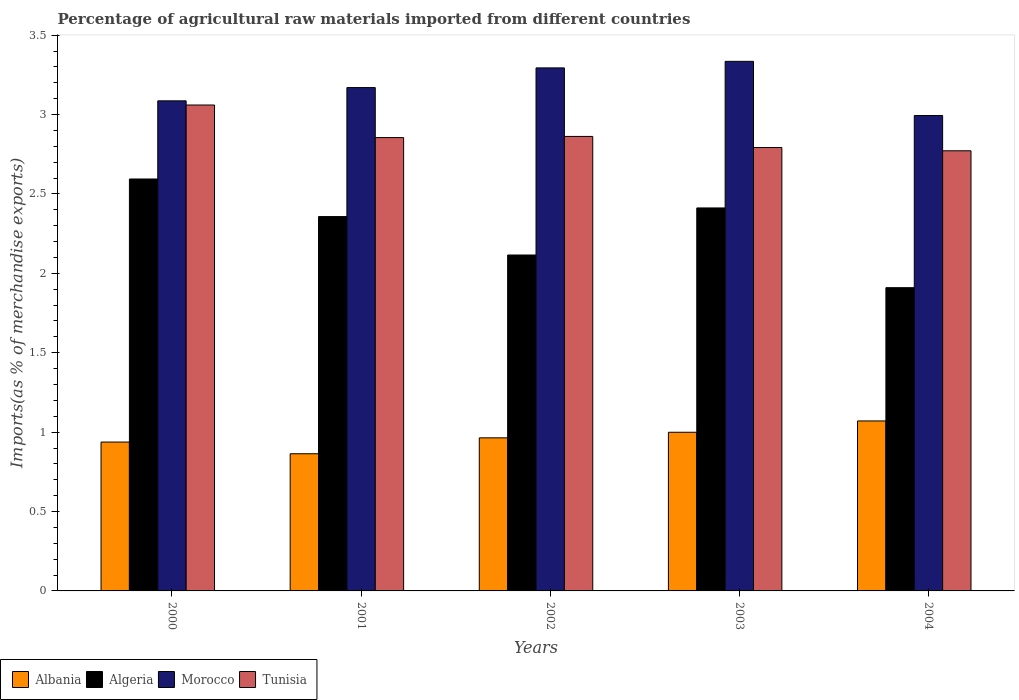How many groups of bars are there?
Provide a short and direct response. 5. In how many cases, is the number of bars for a given year not equal to the number of legend labels?
Give a very brief answer. 0. What is the percentage of imports to different countries in Tunisia in 2003?
Give a very brief answer. 2.79. Across all years, what is the maximum percentage of imports to different countries in Albania?
Provide a succinct answer. 1.07. Across all years, what is the minimum percentage of imports to different countries in Morocco?
Provide a short and direct response. 2.99. In which year was the percentage of imports to different countries in Tunisia minimum?
Ensure brevity in your answer.  2004. What is the total percentage of imports to different countries in Tunisia in the graph?
Keep it short and to the point. 14.34. What is the difference between the percentage of imports to different countries in Albania in 2002 and that in 2003?
Your response must be concise. -0.04. What is the difference between the percentage of imports to different countries in Tunisia in 2000 and the percentage of imports to different countries in Albania in 2001?
Your answer should be very brief. 2.2. What is the average percentage of imports to different countries in Algeria per year?
Provide a succinct answer. 2.28. In the year 2001, what is the difference between the percentage of imports to different countries in Tunisia and percentage of imports to different countries in Albania?
Your response must be concise. 1.99. What is the ratio of the percentage of imports to different countries in Albania in 2002 to that in 2004?
Offer a very short reply. 0.9. Is the percentage of imports to different countries in Algeria in 2003 less than that in 2004?
Offer a very short reply. No. Is the difference between the percentage of imports to different countries in Tunisia in 2001 and 2004 greater than the difference between the percentage of imports to different countries in Albania in 2001 and 2004?
Your answer should be very brief. Yes. What is the difference between the highest and the second highest percentage of imports to different countries in Albania?
Your answer should be compact. 0.07. What is the difference between the highest and the lowest percentage of imports to different countries in Algeria?
Provide a short and direct response. 0.68. Is the sum of the percentage of imports to different countries in Tunisia in 2002 and 2004 greater than the maximum percentage of imports to different countries in Albania across all years?
Your response must be concise. Yes. Is it the case that in every year, the sum of the percentage of imports to different countries in Tunisia and percentage of imports to different countries in Morocco is greater than the sum of percentage of imports to different countries in Albania and percentage of imports to different countries in Algeria?
Give a very brief answer. Yes. What does the 3rd bar from the left in 2004 represents?
Offer a very short reply. Morocco. What does the 2nd bar from the right in 2003 represents?
Your response must be concise. Morocco. How many bars are there?
Your answer should be very brief. 20. Are all the bars in the graph horizontal?
Offer a very short reply. No. How many years are there in the graph?
Give a very brief answer. 5. Are the values on the major ticks of Y-axis written in scientific E-notation?
Make the answer very short. No. Does the graph contain any zero values?
Provide a short and direct response. No. How many legend labels are there?
Provide a short and direct response. 4. How are the legend labels stacked?
Ensure brevity in your answer.  Horizontal. What is the title of the graph?
Provide a succinct answer. Percentage of agricultural raw materials imported from different countries. What is the label or title of the Y-axis?
Ensure brevity in your answer.  Imports(as % of merchandise exports). What is the Imports(as % of merchandise exports) of Albania in 2000?
Ensure brevity in your answer.  0.94. What is the Imports(as % of merchandise exports) in Algeria in 2000?
Ensure brevity in your answer.  2.59. What is the Imports(as % of merchandise exports) in Morocco in 2000?
Keep it short and to the point. 3.09. What is the Imports(as % of merchandise exports) in Tunisia in 2000?
Offer a very short reply. 3.06. What is the Imports(as % of merchandise exports) in Albania in 2001?
Give a very brief answer. 0.86. What is the Imports(as % of merchandise exports) in Algeria in 2001?
Offer a terse response. 2.36. What is the Imports(as % of merchandise exports) of Morocco in 2001?
Your answer should be compact. 3.17. What is the Imports(as % of merchandise exports) of Tunisia in 2001?
Offer a very short reply. 2.85. What is the Imports(as % of merchandise exports) in Albania in 2002?
Provide a succinct answer. 0.96. What is the Imports(as % of merchandise exports) in Algeria in 2002?
Provide a succinct answer. 2.12. What is the Imports(as % of merchandise exports) of Morocco in 2002?
Ensure brevity in your answer.  3.29. What is the Imports(as % of merchandise exports) in Tunisia in 2002?
Provide a succinct answer. 2.86. What is the Imports(as % of merchandise exports) in Albania in 2003?
Ensure brevity in your answer.  1. What is the Imports(as % of merchandise exports) in Algeria in 2003?
Your answer should be compact. 2.41. What is the Imports(as % of merchandise exports) of Morocco in 2003?
Give a very brief answer. 3.34. What is the Imports(as % of merchandise exports) of Tunisia in 2003?
Make the answer very short. 2.79. What is the Imports(as % of merchandise exports) in Albania in 2004?
Keep it short and to the point. 1.07. What is the Imports(as % of merchandise exports) of Algeria in 2004?
Give a very brief answer. 1.91. What is the Imports(as % of merchandise exports) of Morocco in 2004?
Keep it short and to the point. 2.99. What is the Imports(as % of merchandise exports) of Tunisia in 2004?
Provide a succinct answer. 2.77. Across all years, what is the maximum Imports(as % of merchandise exports) of Albania?
Your answer should be very brief. 1.07. Across all years, what is the maximum Imports(as % of merchandise exports) of Algeria?
Give a very brief answer. 2.59. Across all years, what is the maximum Imports(as % of merchandise exports) of Morocco?
Your response must be concise. 3.34. Across all years, what is the maximum Imports(as % of merchandise exports) in Tunisia?
Your answer should be compact. 3.06. Across all years, what is the minimum Imports(as % of merchandise exports) of Albania?
Offer a very short reply. 0.86. Across all years, what is the minimum Imports(as % of merchandise exports) in Algeria?
Offer a terse response. 1.91. Across all years, what is the minimum Imports(as % of merchandise exports) in Morocco?
Ensure brevity in your answer.  2.99. Across all years, what is the minimum Imports(as % of merchandise exports) of Tunisia?
Make the answer very short. 2.77. What is the total Imports(as % of merchandise exports) of Albania in the graph?
Give a very brief answer. 4.84. What is the total Imports(as % of merchandise exports) in Algeria in the graph?
Make the answer very short. 11.39. What is the total Imports(as % of merchandise exports) in Morocco in the graph?
Ensure brevity in your answer.  15.88. What is the total Imports(as % of merchandise exports) in Tunisia in the graph?
Provide a short and direct response. 14.34. What is the difference between the Imports(as % of merchandise exports) in Albania in 2000 and that in 2001?
Provide a succinct answer. 0.07. What is the difference between the Imports(as % of merchandise exports) of Algeria in 2000 and that in 2001?
Your response must be concise. 0.24. What is the difference between the Imports(as % of merchandise exports) of Morocco in 2000 and that in 2001?
Provide a short and direct response. -0.08. What is the difference between the Imports(as % of merchandise exports) in Tunisia in 2000 and that in 2001?
Provide a short and direct response. 0.21. What is the difference between the Imports(as % of merchandise exports) in Albania in 2000 and that in 2002?
Keep it short and to the point. -0.03. What is the difference between the Imports(as % of merchandise exports) in Algeria in 2000 and that in 2002?
Ensure brevity in your answer.  0.48. What is the difference between the Imports(as % of merchandise exports) in Morocco in 2000 and that in 2002?
Your answer should be compact. -0.21. What is the difference between the Imports(as % of merchandise exports) of Tunisia in 2000 and that in 2002?
Provide a succinct answer. 0.2. What is the difference between the Imports(as % of merchandise exports) of Albania in 2000 and that in 2003?
Ensure brevity in your answer.  -0.06. What is the difference between the Imports(as % of merchandise exports) of Algeria in 2000 and that in 2003?
Give a very brief answer. 0.18. What is the difference between the Imports(as % of merchandise exports) of Morocco in 2000 and that in 2003?
Provide a short and direct response. -0.25. What is the difference between the Imports(as % of merchandise exports) of Tunisia in 2000 and that in 2003?
Provide a succinct answer. 0.27. What is the difference between the Imports(as % of merchandise exports) in Albania in 2000 and that in 2004?
Provide a succinct answer. -0.13. What is the difference between the Imports(as % of merchandise exports) of Algeria in 2000 and that in 2004?
Offer a terse response. 0.68. What is the difference between the Imports(as % of merchandise exports) in Morocco in 2000 and that in 2004?
Your answer should be very brief. 0.09. What is the difference between the Imports(as % of merchandise exports) in Tunisia in 2000 and that in 2004?
Your answer should be very brief. 0.29. What is the difference between the Imports(as % of merchandise exports) of Albania in 2001 and that in 2002?
Your answer should be compact. -0.1. What is the difference between the Imports(as % of merchandise exports) in Algeria in 2001 and that in 2002?
Provide a short and direct response. 0.24. What is the difference between the Imports(as % of merchandise exports) in Morocco in 2001 and that in 2002?
Provide a succinct answer. -0.12. What is the difference between the Imports(as % of merchandise exports) in Tunisia in 2001 and that in 2002?
Provide a short and direct response. -0.01. What is the difference between the Imports(as % of merchandise exports) of Albania in 2001 and that in 2003?
Give a very brief answer. -0.14. What is the difference between the Imports(as % of merchandise exports) in Algeria in 2001 and that in 2003?
Your answer should be very brief. -0.05. What is the difference between the Imports(as % of merchandise exports) of Morocco in 2001 and that in 2003?
Provide a succinct answer. -0.17. What is the difference between the Imports(as % of merchandise exports) of Tunisia in 2001 and that in 2003?
Offer a terse response. 0.06. What is the difference between the Imports(as % of merchandise exports) of Albania in 2001 and that in 2004?
Offer a very short reply. -0.21. What is the difference between the Imports(as % of merchandise exports) in Algeria in 2001 and that in 2004?
Offer a very short reply. 0.45. What is the difference between the Imports(as % of merchandise exports) in Morocco in 2001 and that in 2004?
Make the answer very short. 0.18. What is the difference between the Imports(as % of merchandise exports) of Tunisia in 2001 and that in 2004?
Provide a succinct answer. 0.08. What is the difference between the Imports(as % of merchandise exports) in Albania in 2002 and that in 2003?
Offer a terse response. -0.04. What is the difference between the Imports(as % of merchandise exports) of Algeria in 2002 and that in 2003?
Offer a terse response. -0.3. What is the difference between the Imports(as % of merchandise exports) in Morocco in 2002 and that in 2003?
Ensure brevity in your answer.  -0.04. What is the difference between the Imports(as % of merchandise exports) of Tunisia in 2002 and that in 2003?
Your answer should be compact. 0.07. What is the difference between the Imports(as % of merchandise exports) of Albania in 2002 and that in 2004?
Keep it short and to the point. -0.11. What is the difference between the Imports(as % of merchandise exports) of Algeria in 2002 and that in 2004?
Your response must be concise. 0.21. What is the difference between the Imports(as % of merchandise exports) of Morocco in 2002 and that in 2004?
Provide a succinct answer. 0.3. What is the difference between the Imports(as % of merchandise exports) in Tunisia in 2002 and that in 2004?
Ensure brevity in your answer.  0.09. What is the difference between the Imports(as % of merchandise exports) in Albania in 2003 and that in 2004?
Keep it short and to the point. -0.07. What is the difference between the Imports(as % of merchandise exports) of Algeria in 2003 and that in 2004?
Your answer should be very brief. 0.5. What is the difference between the Imports(as % of merchandise exports) in Morocco in 2003 and that in 2004?
Make the answer very short. 0.34. What is the difference between the Imports(as % of merchandise exports) in Tunisia in 2003 and that in 2004?
Keep it short and to the point. 0.02. What is the difference between the Imports(as % of merchandise exports) of Albania in 2000 and the Imports(as % of merchandise exports) of Algeria in 2001?
Ensure brevity in your answer.  -1.42. What is the difference between the Imports(as % of merchandise exports) in Albania in 2000 and the Imports(as % of merchandise exports) in Morocco in 2001?
Offer a terse response. -2.23. What is the difference between the Imports(as % of merchandise exports) in Albania in 2000 and the Imports(as % of merchandise exports) in Tunisia in 2001?
Provide a succinct answer. -1.92. What is the difference between the Imports(as % of merchandise exports) in Algeria in 2000 and the Imports(as % of merchandise exports) in Morocco in 2001?
Ensure brevity in your answer.  -0.58. What is the difference between the Imports(as % of merchandise exports) in Algeria in 2000 and the Imports(as % of merchandise exports) in Tunisia in 2001?
Keep it short and to the point. -0.26. What is the difference between the Imports(as % of merchandise exports) of Morocco in 2000 and the Imports(as % of merchandise exports) of Tunisia in 2001?
Provide a succinct answer. 0.23. What is the difference between the Imports(as % of merchandise exports) in Albania in 2000 and the Imports(as % of merchandise exports) in Algeria in 2002?
Offer a very short reply. -1.18. What is the difference between the Imports(as % of merchandise exports) of Albania in 2000 and the Imports(as % of merchandise exports) of Morocco in 2002?
Your response must be concise. -2.36. What is the difference between the Imports(as % of merchandise exports) in Albania in 2000 and the Imports(as % of merchandise exports) in Tunisia in 2002?
Your answer should be compact. -1.92. What is the difference between the Imports(as % of merchandise exports) of Algeria in 2000 and the Imports(as % of merchandise exports) of Morocco in 2002?
Make the answer very short. -0.7. What is the difference between the Imports(as % of merchandise exports) of Algeria in 2000 and the Imports(as % of merchandise exports) of Tunisia in 2002?
Offer a terse response. -0.27. What is the difference between the Imports(as % of merchandise exports) of Morocco in 2000 and the Imports(as % of merchandise exports) of Tunisia in 2002?
Your response must be concise. 0.22. What is the difference between the Imports(as % of merchandise exports) of Albania in 2000 and the Imports(as % of merchandise exports) of Algeria in 2003?
Provide a short and direct response. -1.47. What is the difference between the Imports(as % of merchandise exports) of Albania in 2000 and the Imports(as % of merchandise exports) of Morocco in 2003?
Keep it short and to the point. -2.4. What is the difference between the Imports(as % of merchandise exports) of Albania in 2000 and the Imports(as % of merchandise exports) of Tunisia in 2003?
Ensure brevity in your answer.  -1.85. What is the difference between the Imports(as % of merchandise exports) of Algeria in 2000 and the Imports(as % of merchandise exports) of Morocco in 2003?
Keep it short and to the point. -0.74. What is the difference between the Imports(as % of merchandise exports) of Algeria in 2000 and the Imports(as % of merchandise exports) of Tunisia in 2003?
Provide a succinct answer. -0.2. What is the difference between the Imports(as % of merchandise exports) of Morocco in 2000 and the Imports(as % of merchandise exports) of Tunisia in 2003?
Your answer should be compact. 0.29. What is the difference between the Imports(as % of merchandise exports) in Albania in 2000 and the Imports(as % of merchandise exports) in Algeria in 2004?
Give a very brief answer. -0.97. What is the difference between the Imports(as % of merchandise exports) in Albania in 2000 and the Imports(as % of merchandise exports) in Morocco in 2004?
Provide a short and direct response. -2.06. What is the difference between the Imports(as % of merchandise exports) of Albania in 2000 and the Imports(as % of merchandise exports) of Tunisia in 2004?
Your answer should be very brief. -1.83. What is the difference between the Imports(as % of merchandise exports) of Algeria in 2000 and the Imports(as % of merchandise exports) of Morocco in 2004?
Keep it short and to the point. -0.4. What is the difference between the Imports(as % of merchandise exports) in Algeria in 2000 and the Imports(as % of merchandise exports) in Tunisia in 2004?
Give a very brief answer. -0.18. What is the difference between the Imports(as % of merchandise exports) of Morocco in 2000 and the Imports(as % of merchandise exports) of Tunisia in 2004?
Ensure brevity in your answer.  0.31. What is the difference between the Imports(as % of merchandise exports) of Albania in 2001 and the Imports(as % of merchandise exports) of Algeria in 2002?
Your answer should be very brief. -1.25. What is the difference between the Imports(as % of merchandise exports) in Albania in 2001 and the Imports(as % of merchandise exports) in Morocco in 2002?
Provide a succinct answer. -2.43. What is the difference between the Imports(as % of merchandise exports) of Albania in 2001 and the Imports(as % of merchandise exports) of Tunisia in 2002?
Your response must be concise. -2. What is the difference between the Imports(as % of merchandise exports) in Algeria in 2001 and the Imports(as % of merchandise exports) in Morocco in 2002?
Your answer should be very brief. -0.94. What is the difference between the Imports(as % of merchandise exports) of Algeria in 2001 and the Imports(as % of merchandise exports) of Tunisia in 2002?
Ensure brevity in your answer.  -0.5. What is the difference between the Imports(as % of merchandise exports) of Morocco in 2001 and the Imports(as % of merchandise exports) of Tunisia in 2002?
Make the answer very short. 0.31. What is the difference between the Imports(as % of merchandise exports) of Albania in 2001 and the Imports(as % of merchandise exports) of Algeria in 2003?
Keep it short and to the point. -1.55. What is the difference between the Imports(as % of merchandise exports) of Albania in 2001 and the Imports(as % of merchandise exports) of Morocco in 2003?
Your response must be concise. -2.47. What is the difference between the Imports(as % of merchandise exports) in Albania in 2001 and the Imports(as % of merchandise exports) in Tunisia in 2003?
Provide a succinct answer. -1.93. What is the difference between the Imports(as % of merchandise exports) in Algeria in 2001 and the Imports(as % of merchandise exports) in Morocco in 2003?
Provide a succinct answer. -0.98. What is the difference between the Imports(as % of merchandise exports) in Algeria in 2001 and the Imports(as % of merchandise exports) in Tunisia in 2003?
Give a very brief answer. -0.43. What is the difference between the Imports(as % of merchandise exports) of Morocco in 2001 and the Imports(as % of merchandise exports) of Tunisia in 2003?
Provide a short and direct response. 0.38. What is the difference between the Imports(as % of merchandise exports) of Albania in 2001 and the Imports(as % of merchandise exports) of Algeria in 2004?
Your answer should be compact. -1.05. What is the difference between the Imports(as % of merchandise exports) in Albania in 2001 and the Imports(as % of merchandise exports) in Morocco in 2004?
Your response must be concise. -2.13. What is the difference between the Imports(as % of merchandise exports) in Albania in 2001 and the Imports(as % of merchandise exports) in Tunisia in 2004?
Provide a short and direct response. -1.91. What is the difference between the Imports(as % of merchandise exports) in Algeria in 2001 and the Imports(as % of merchandise exports) in Morocco in 2004?
Ensure brevity in your answer.  -0.64. What is the difference between the Imports(as % of merchandise exports) in Algeria in 2001 and the Imports(as % of merchandise exports) in Tunisia in 2004?
Provide a succinct answer. -0.41. What is the difference between the Imports(as % of merchandise exports) in Morocco in 2001 and the Imports(as % of merchandise exports) in Tunisia in 2004?
Ensure brevity in your answer.  0.4. What is the difference between the Imports(as % of merchandise exports) in Albania in 2002 and the Imports(as % of merchandise exports) in Algeria in 2003?
Keep it short and to the point. -1.45. What is the difference between the Imports(as % of merchandise exports) in Albania in 2002 and the Imports(as % of merchandise exports) in Morocco in 2003?
Provide a short and direct response. -2.37. What is the difference between the Imports(as % of merchandise exports) in Albania in 2002 and the Imports(as % of merchandise exports) in Tunisia in 2003?
Offer a terse response. -1.83. What is the difference between the Imports(as % of merchandise exports) in Algeria in 2002 and the Imports(as % of merchandise exports) in Morocco in 2003?
Your response must be concise. -1.22. What is the difference between the Imports(as % of merchandise exports) of Algeria in 2002 and the Imports(as % of merchandise exports) of Tunisia in 2003?
Offer a terse response. -0.68. What is the difference between the Imports(as % of merchandise exports) in Morocco in 2002 and the Imports(as % of merchandise exports) in Tunisia in 2003?
Offer a very short reply. 0.5. What is the difference between the Imports(as % of merchandise exports) in Albania in 2002 and the Imports(as % of merchandise exports) in Algeria in 2004?
Make the answer very short. -0.95. What is the difference between the Imports(as % of merchandise exports) in Albania in 2002 and the Imports(as % of merchandise exports) in Morocco in 2004?
Make the answer very short. -2.03. What is the difference between the Imports(as % of merchandise exports) of Albania in 2002 and the Imports(as % of merchandise exports) of Tunisia in 2004?
Your response must be concise. -1.81. What is the difference between the Imports(as % of merchandise exports) in Algeria in 2002 and the Imports(as % of merchandise exports) in Morocco in 2004?
Give a very brief answer. -0.88. What is the difference between the Imports(as % of merchandise exports) in Algeria in 2002 and the Imports(as % of merchandise exports) in Tunisia in 2004?
Offer a very short reply. -0.66. What is the difference between the Imports(as % of merchandise exports) of Morocco in 2002 and the Imports(as % of merchandise exports) of Tunisia in 2004?
Offer a very short reply. 0.52. What is the difference between the Imports(as % of merchandise exports) in Albania in 2003 and the Imports(as % of merchandise exports) in Algeria in 2004?
Ensure brevity in your answer.  -0.91. What is the difference between the Imports(as % of merchandise exports) in Albania in 2003 and the Imports(as % of merchandise exports) in Morocco in 2004?
Your answer should be very brief. -1.99. What is the difference between the Imports(as % of merchandise exports) of Albania in 2003 and the Imports(as % of merchandise exports) of Tunisia in 2004?
Offer a very short reply. -1.77. What is the difference between the Imports(as % of merchandise exports) of Algeria in 2003 and the Imports(as % of merchandise exports) of Morocco in 2004?
Your answer should be compact. -0.58. What is the difference between the Imports(as % of merchandise exports) of Algeria in 2003 and the Imports(as % of merchandise exports) of Tunisia in 2004?
Give a very brief answer. -0.36. What is the difference between the Imports(as % of merchandise exports) of Morocco in 2003 and the Imports(as % of merchandise exports) of Tunisia in 2004?
Your answer should be very brief. 0.56. What is the average Imports(as % of merchandise exports) in Algeria per year?
Offer a very short reply. 2.28. What is the average Imports(as % of merchandise exports) in Morocco per year?
Offer a very short reply. 3.18. What is the average Imports(as % of merchandise exports) of Tunisia per year?
Keep it short and to the point. 2.87. In the year 2000, what is the difference between the Imports(as % of merchandise exports) of Albania and Imports(as % of merchandise exports) of Algeria?
Give a very brief answer. -1.66. In the year 2000, what is the difference between the Imports(as % of merchandise exports) in Albania and Imports(as % of merchandise exports) in Morocco?
Provide a succinct answer. -2.15. In the year 2000, what is the difference between the Imports(as % of merchandise exports) in Albania and Imports(as % of merchandise exports) in Tunisia?
Give a very brief answer. -2.12. In the year 2000, what is the difference between the Imports(as % of merchandise exports) of Algeria and Imports(as % of merchandise exports) of Morocco?
Your answer should be very brief. -0.49. In the year 2000, what is the difference between the Imports(as % of merchandise exports) of Algeria and Imports(as % of merchandise exports) of Tunisia?
Provide a succinct answer. -0.47. In the year 2000, what is the difference between the Imports(as % of merchandise exports) in Morocco and Imports(as % of merchandise exports) in Tunisia?
Offer a very short reply. 0.03. In the year 2001, what is the difference between the Imports(as % of merchandise exports) of Albania and Imports(as % of merchandise exports) of Algeria?
Keep it short and to the point. -1.49. In the year 2001, what is the difference between the Imports(as % of merchandise exports) in Albania and Imports(as % of merchandise exports) in Morocco?
Offer a terse response. -2.31. In the year 2001, what is the difference between the Imports(as % of merchandise exports) of Albania and Imports(as % of merchandise exports) of Tunisia?
Offer a terse response. -1.99. In the year 2001, what is the difference between the Imports(as % of merchandise exports) in Algeria and Imports(as % of merchandise exports) in Morocco?
Your answer should be very brief. -0.81. In the year 2001, what is the difference between the Imports(as % of merchandise exports) in Algeria and Imports(as % of merchandise exports) in Tunisia?
Make the answer very short. -0.5. In the year 2001, what is the difference between the Imports(as % of merchandise exports) in Morocco and Imports(as % of merchandise exports) in Tunisia?
Ensure brevity in your answer.  0.32. In the year 2002, what is the difference between the Imports(as % of merchandise exports) of Albania and Imports(as % of merchandise exports) of Algeria?
Provide a short and direct response. -1.15. In the year 2002, what is the difference between the Imports(as % of merchandise exports) of Albania and Imports(as % of merchandise exports) of Morocco?
Provide a short and direct response. -2.33. In the year 2002, what is the difference between the Imports(as % of merchandise exports) of Albania and Imports(as % of merchandise exports) of Tunisia?
Ensure brevity in your answer.  -1.9. In the year 2002, what is the difference between the Imports(as % of merchandise exports) in Algeria and Imports(as % of merchandise exports) in Morocco?
Your answer should be very brief. -1.18. In the year 2002, what is the difference between the Imports(as % of merchandise exports) of Algeria and Imports(as % of merchandise exports) of Tunisia?
Your answer should be very brief. -0.75. In the year 2002, what is the difference between the Imports(as % of merchandise exports) in Morocco and Imports(as % of merchandise exports) in Tunisia?
Offer a very short reply. 0.43. In the year 2003, what is the difference between the Imports(as % of merchandise exports) of Albania and Imports(as % of merchandise exports) of Algeria?
Offer a terse response. -1.41. In the year 2003, what is the difference between the Imports(as % of merchandise exports) in Albania and Imports(as % of merchandise exports) in Morocco?
Keep it short and to the point. -2.34. In the year 2003, what is the difference between the Imports(as % of merchandise exports) in Albania and Imports(as % of merchandise exports) in Tunisia?
Keep it short and to the point. -1.79. In the year 2003, what is the difference between the Imports(as % of merchandise exports) in Algeria and Imports(as % of merchandise exports) in Morocco?
Provide a succinct answer. -0.92. In the year 2003, what is the difference between the Imports(as % of merchandise exports) of Algeria and Imports(as % of merchandise exports) of Tunisia?
Provide a short and direct response. -0.38. In the year 2003, what is the difference between the Imports(as % of merchandise exports) of Morocco and Imports(as % of merchandise exports) of Tunisia?
Offer a terse response. 0.54. In the year 2004, what is the difference between the Imports(as % of merchandise exports) in Albania and Imports(as % of merchandise exports) in Algeria?
Keep it short and to the point. -0.84. In the year 2004, what is the difference between the Imports(as % of merchandise exports) of Albania and Imports(as % of merchandise exports) of Morocco?
Offer a terse response. -1.92. In the year 2004, what is the difference between the Imports(as % of merchandise exports) of Albania and Imports(as % of merchandise exports) of Tunisia?
Keep it short and to the point. -1.7. In the year 2004, what is the difference between the Imports(as % of merchandise exports) of Algeria and Imports(as % of merchandise exports) of Morocco?
Your response must be concise. -1.08. In the year 2004, what is the difference between the Imports(as % of merchandise exports) of Algeria and Imports(as % of merchandise exports) of Tunisia?
Offer a terse response. -0.86. In the year 2004, what is the difference between the Imports(as % of merchandise exports) of Morocco and Imports(as % of merchandise exports) of Tunisia?
Ensure brevity in your answer.  0.22. What is the ratio of the Imports(as % of merchandise exports) of Albania in 2000 to that in 2001?
Offer a very short reply. 1.09. What is the ratio of the Imports(as % of merchandise exports) of Algeria in 2000 to that in 2001?
Keep it short and to the point. 1.1. What is the ratio of the Imports(as % of merchandise exports) of Morocco in 2000 to that in 2001?
Your response must be concise. 0.97. What is the ratio of the Imports(as % of merchandise exports) of Tunisia in 2000 to that in 2001?
Your answer should be compact. 1.07. What is the ratio of the Imports(as % of merchandise exports) of Albania in 2000 to that in 2002?
Your answer should be very brief. 0.97. What is the ratio of the Imports(as % of merchandise exports) of Algeria in 2000 to that in 2002?
Keep it short and to the point. 1.23. What is the ratio of the Imports(as % of merchandise exports) of Morocco in 2000 to that in 2002?
Ensure brevity in your answer.  0.94. What is the ratio of the Imports(as % of merchandise exports) of Tunisia in 2000 to that in 2002?
Provide a succinct answer. 1.07. What is the ratio of the Imports(as % of merchandise exports) in Albania in 2000 to that in 2003?
Offer a very short reply. 0.94. What is the ratio of the Imports(as % of merchandise exports) in Algeria in 2000 to that in 2003?
Ensure brevity in your answer.  1.08. What is the ratio of the Imports(as % of merchandise exports) in Morocco in 2000 to that in 2003?
Give a very brief answer. 0.93. What is the ratio of the Imports(as % of merchandise exports) in Tunisia in 2000 to that in 2003?
Your response must be concise. 1.1. What is the ratio of the Imports(as % of merchandise exports) of Albania in 2000 to that in 2004?
Offer a very short reply. 0.88. What is the ratio of the Imports(as % of merchandise exports) of Algeria in 2000 to that in 2004?
Your answer should be compact. 1.36. What is the ratio of the Imports(as % of merchandise exports) of Morocco in 2000 to that in 2004?
Offer a terse response. 1.03. What is the ratio of the Imports(as % of merchandise exports) in Tunisia in 2000 to that in 2004?
Your answer should be very brief. 1.1. What is the ratio of the Imports(as % of merchandise exports) of Albania in 2001 to that in 2002?
Provide a succinct answer. 0.9. What is the ratio of the Imports(as % of merchandise exports) in Algeria in 2001 to that in 2002?
Make the answer very short. 1.11. What is the ratio of the Imports(as % of merchandise exports) of Morocco in 2001 to that in 2002?
Make the answer very short. 0.96. What is the ratio of the Imports(as % of merchandise exports) in Albania in 2001 to that in 2003?
Keep it short and to the point. 0.86. What is the ratio of the Imports(as % of merchandise exports) in Algeria in 2001 to that in 2003?
Provide a short and direct response. 0.98. What is the ratio of the Imports(as % of merchandise exports) of Morocco in 2001 to that in 2003?
Your answer should be compact. 0.95. What is the ratio of the Imports(as % of merchandise exports) in Tunisia in 2001 to that in 2003?
Provide a succinct answer. 1.02. What is the ratio of the Imports(as % of merchandise exports) in Albania in 2001 to that in 2004?
Your response must be concise. 0.81. What is the ratio of the Imports(as % of merchandise exports) in Algeria in 2001 to that in 2004?
Provide a short and direct response. 1.23. What is the ratio of the Imports(as % of merchandise exports) in Morocco in 2001 to that in 2004?
Give a very brief answer. 1.06. What is the ratio of the Imports(as % of merchandise exports) in Tunisia in 2001 to that in 2004?
Your answer should be compact. 1.03. What is the ratio of the Imports(as % of merchandise exports) in Albania in 2002 to that in 2003?
Keep it short and to the point. 0.96. What is the ratio of the Imports(as % of merchandise exports) of Algeria in 2002 to that in 2003?
Offer a very short reply. 0.88. What is the ratio of the Imports(as % of merchandise exports) in Morocco in 2002 to that in 2003?
Give a very brief answer. 0.99. What is the ratio of the Imports(as % of merchandise exports) in Tunisia in 2002 to that in 2003?
Make the answer very short. 1.02. What is the ratio of the Imports(as % of merchandise exports) in Albania in 2002 to that in 2004?
Offer a very short reply. 0.9. What is the ratio of the Imports(as % of merchandise exports) in Algeria in 2002 to that in 2004?
Keep it short and to the point. 1.11. What is the ratio of the Imports(as % of merchandise exports) in Morocco in 2002 to that in 2004?
Your answer should be very brief. 1.1. What is the ratio of the Imports(as % of merchandise exports) in Tunisia in 2002 to that in 2004?
Offer a very short reply. 1.03. What is the ratio of the Imports(as % of merchandise exports) in Albania in 2003 to that in 2004?
Provide a succinct answer. 0.93. What is the ratio of the Imports(as % of merchandise exports) of Algeria in 2003 to that in 2004?
Your answer should be very brief. 1.26. What is the ratio of the Imports(as % of merchandise exports) in Morocco in 2003 to that in 2004?
Offer a very short reply. 1.11. What is the ratio of the Imports(as % of merchandise exports) of Tunisia in 2003 to that in 2004?
Provide a succinct answer. 1.01. What is the difference between the highest and the second highest Imports(as % of merchandise exports) in Albania?
Your response must be concise. 0.07. What is the difference between the highest and the second highest Imports(as % of merchandise exports) in Algeria?
Ensure brevity in your answer.  0.18. What is the difference between the highest and the second highest Imports(as % of merchandise exports) in Morocco?
Provide a short and direct response. 0.04. What is the difference between the highest and the second highest Imports(as % of merchandise exports) in Tunisia?
Give a very brief answer. 0.2. What is the difference between the highest and the lowest Imports(as % of merchandise exports) of Albania?
Keep it short and to the point. 0.21. What is the difference between the highest and the lowest Imports(as % of merchandise exports) of Algeria?
Provide a succinct answer. 0.68. What is the difference between the highest and the lowest Imports(as % of merchandise exports) in Morocco?
Your answer should be compact. 0.34. What is the difference between the highest and the lowest Imports(as % of merchandise exports) of Tunisia?
Offer a terse response. 0.29. 